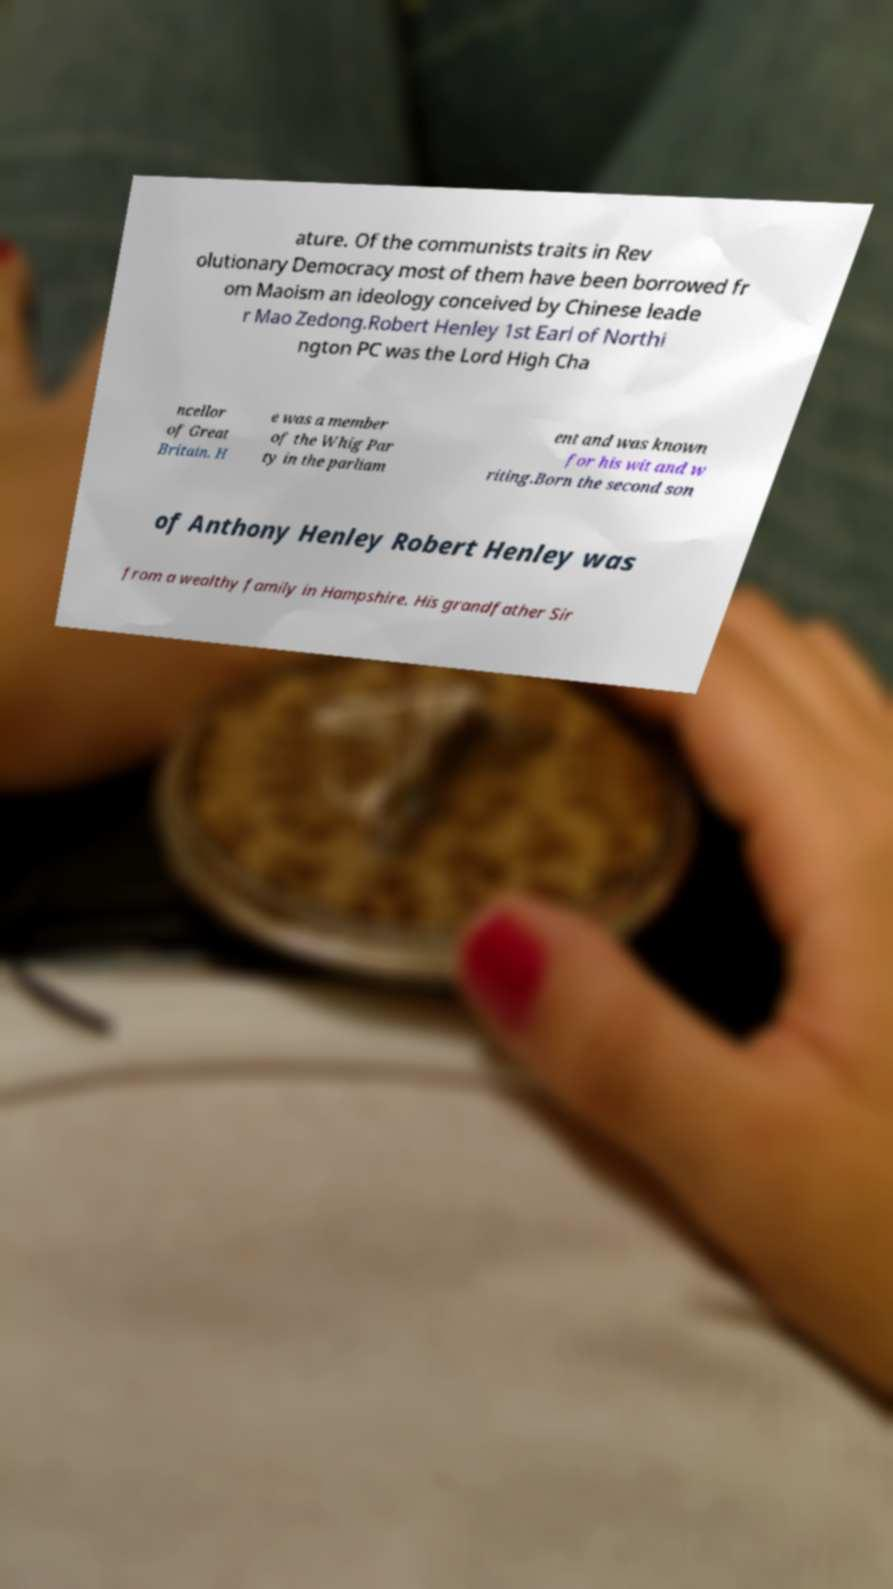For documentation purposes, I need the text within this image transcribed. Could you provide that? ature. Of the communists traits in Rev olutionary Democracy most of them have been borrowed fr om Maoism an ideology conceived by Chinese leade r Mao Zedong.Robert Henley 1st Earl of Northi ngton PC was the Lord High Cha ncellor of Great Britain. H e was a member of the Whig Par ty in the parliam ent and was known for his wit and w riting.Born the second son of Anthony Henley Robert Henley was from a wealthy family in Hampshire. His grandfather Sir 